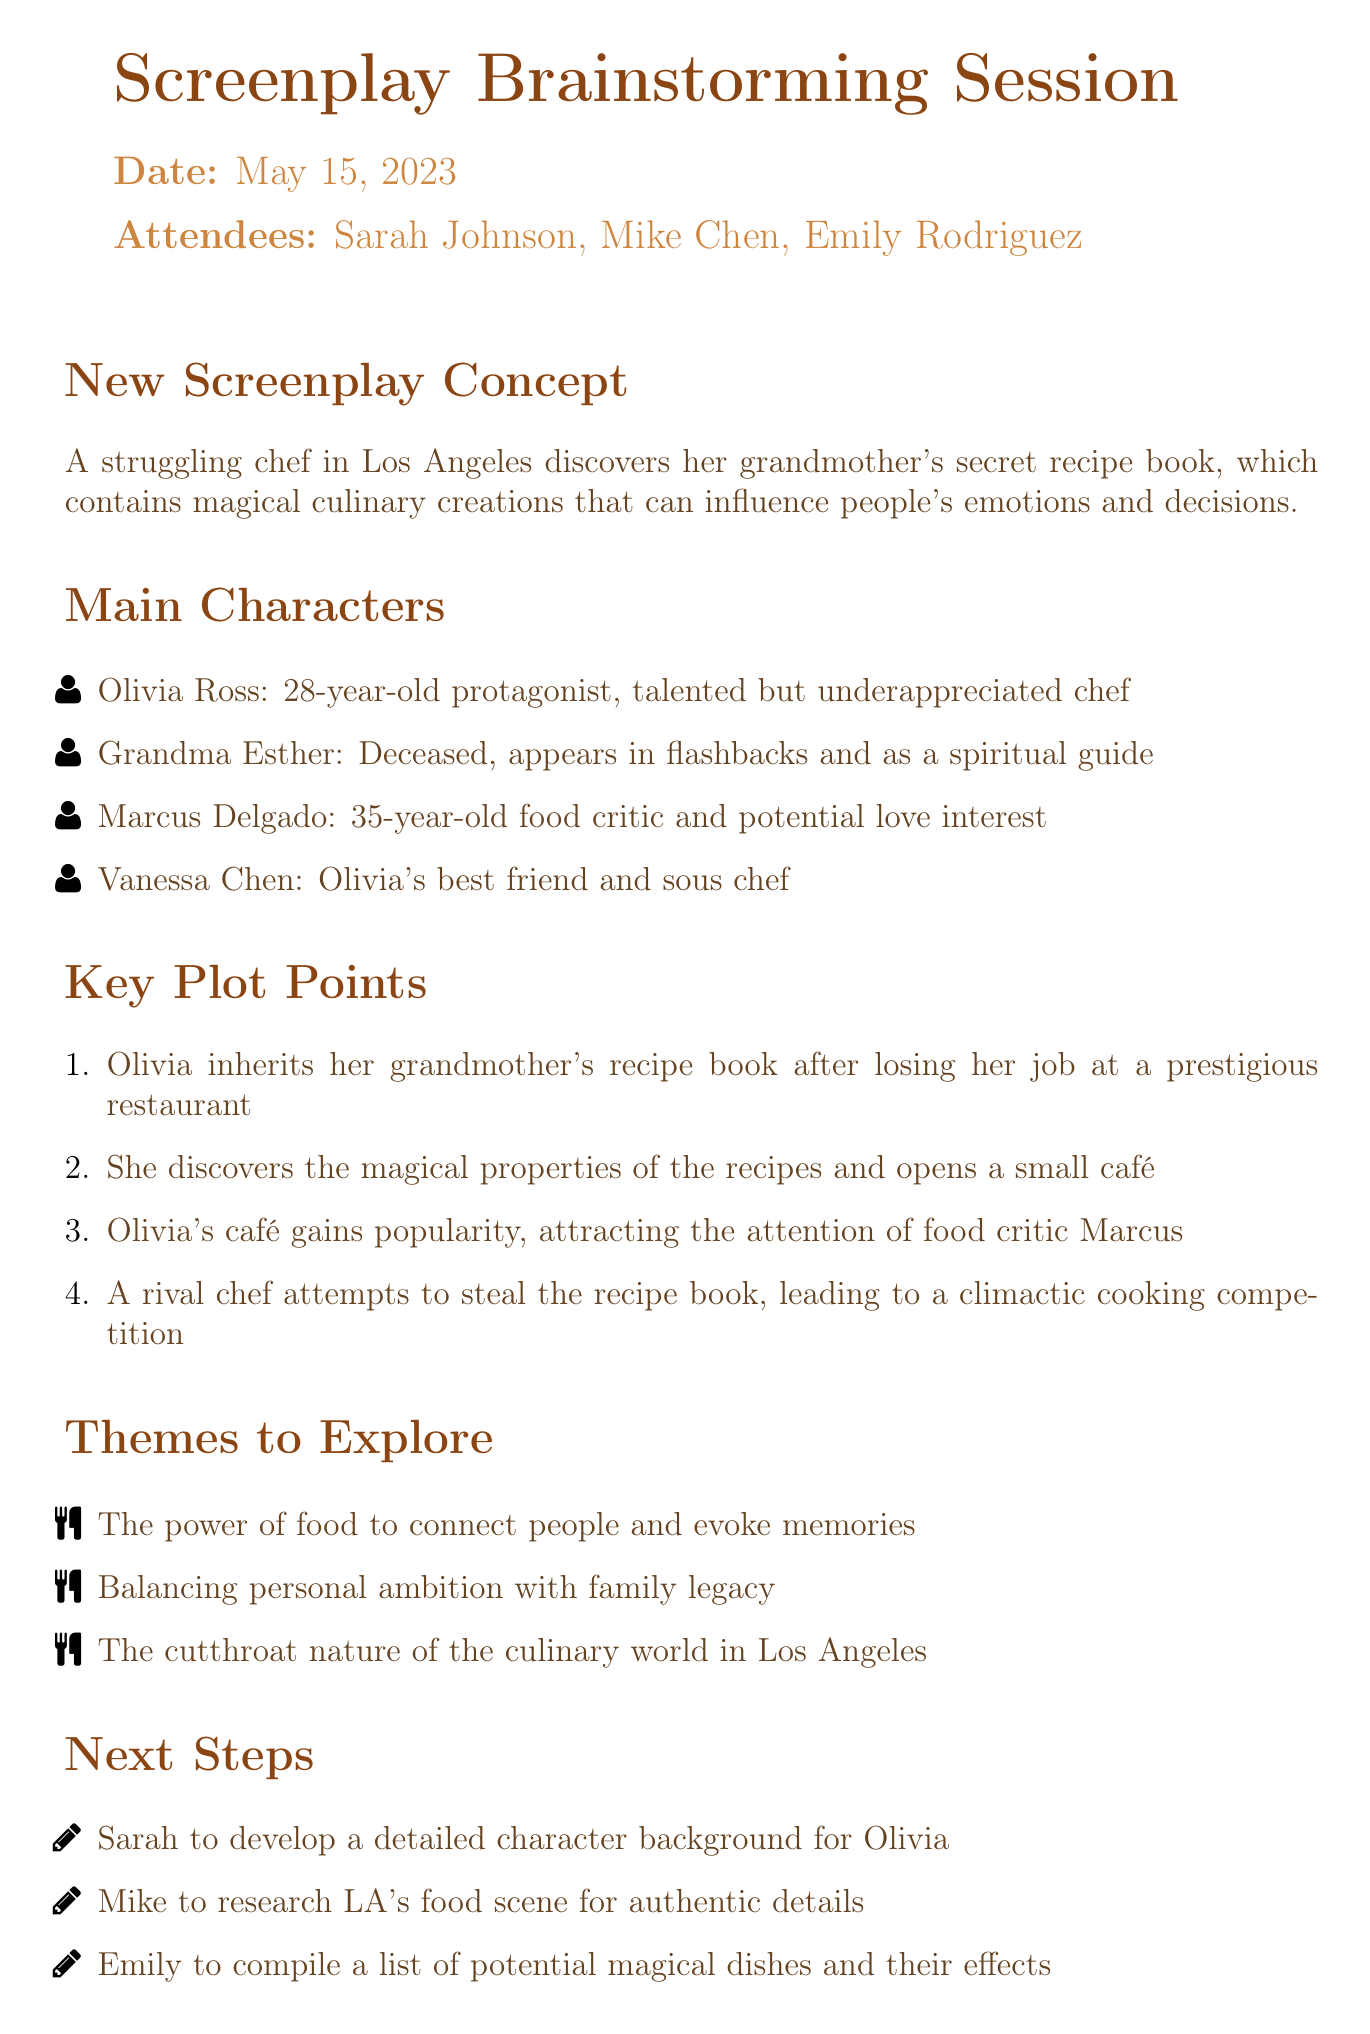What is the date of the meeting? The date of the meeting is specified at the beginning of the document.
Answer: May 15, 2023 Who is the protagonist of the screenplay? The protagonist is listed in the main characters section.
Answer: Olivia Ross What is the age of Marcus Delgado? The age is mentioned next to the character name in the document.
Answer: 35 years old What is the first key plot point? The first key plot point outlines the initial situation for the protagonist.
Answer: Olivia inherits her grandmother's recipe book after losing her job at a prestigious restaurant What theme explores the connection of food with memories? The themes to explore section includes various themes pertaining to the screenplay's narrative.
Answer: The power of food to connect people and evoke memories How many attendees were present at the meeting? The number of attendees is found in the attendees list.
Answer: Three What is the next step assigned to Mike? The next steps section lists actions assigned to each individual present.
Answer: Mike to research LA's food scene for authentic details Why does Olivia open a small café? This can be inferred by understanding her discovery of the magical properties of the recipes.
Answer: She discovers the magical properties of the recipes What is the occupation of Grandma Esther? The description in the main characters section provides insight into her role.
Answer: Deceased 